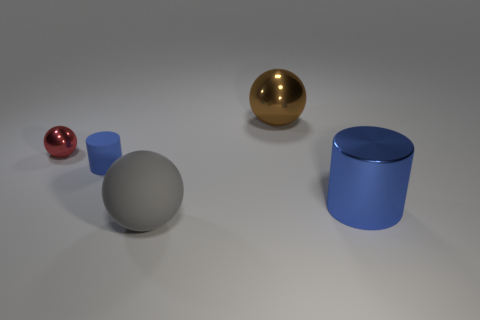Are the blue cylinder that is to the right of the large metallic sphere and the large brown thing made of the same material?
Your answer should be compact. Yes. There is a gray object that is the same size as the blue metallic cylinder; what material is it?
Your answer should be very brief. Rubber. How many other things are there of the same material as the tiny red ball?
Provide a succinct answer. 2. There is a gray rubber thing; does it have the same size as the blue cylinder that is behind the big blue shiny object?
Offer a very short reply. No. Are there fewer gray rubber things on the right side of the blue shiny cylinder than balls in front of the big shiny ball?
Keep it short and to the point. Yes. How big is the cylinder that is on the left side of the large gray thing?
Give a very brief answer. Small. Does the blue rubber cylinder have the same size as the red shiny thing?
Offer a terse response. Yes. What number of things are behind the small rubber object and in front of the large metallic sphere?
Your response must be concise. 1. What number of blue things are large matte things or small cylinders?
Make the answer very short. 1. How many matte things are large blue cylinders or small blue cylinders?
Your answer should be very brief. 1. 